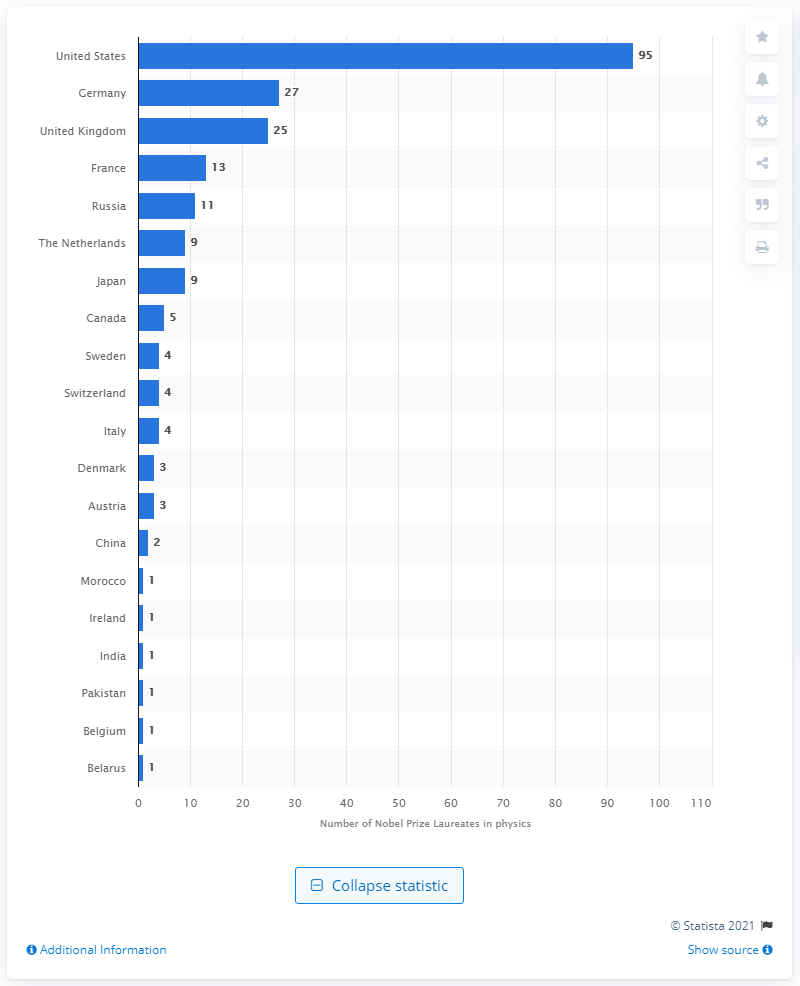Outline some significant characteristics in this image. Approximately 95 Americans have won the Nobel Prize in physics between 1901 and 2020. Since 1901, a total of 27 Nobel Prize Laureates have been awarded to individuals from Germany. 